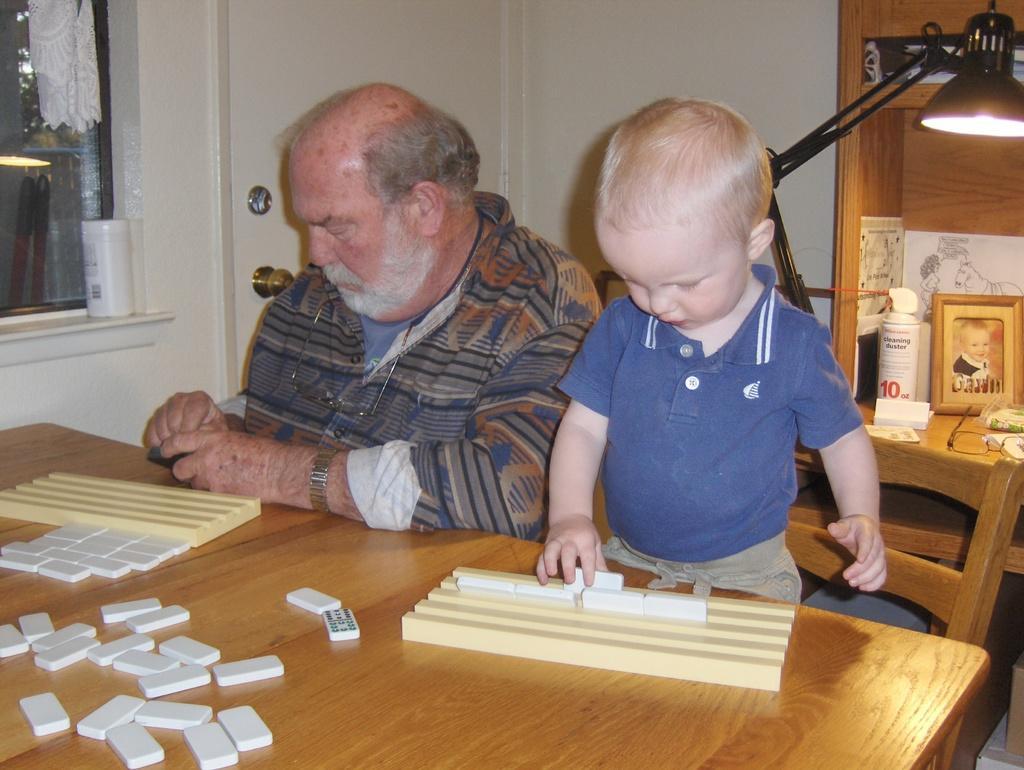How would you summarize this image in a sentence or two? A old man is sitting on the chair and a kid is standing on the chair. On the table we can see some puzzle blocks. In the background there is a lamp,photo frame,door and window. 